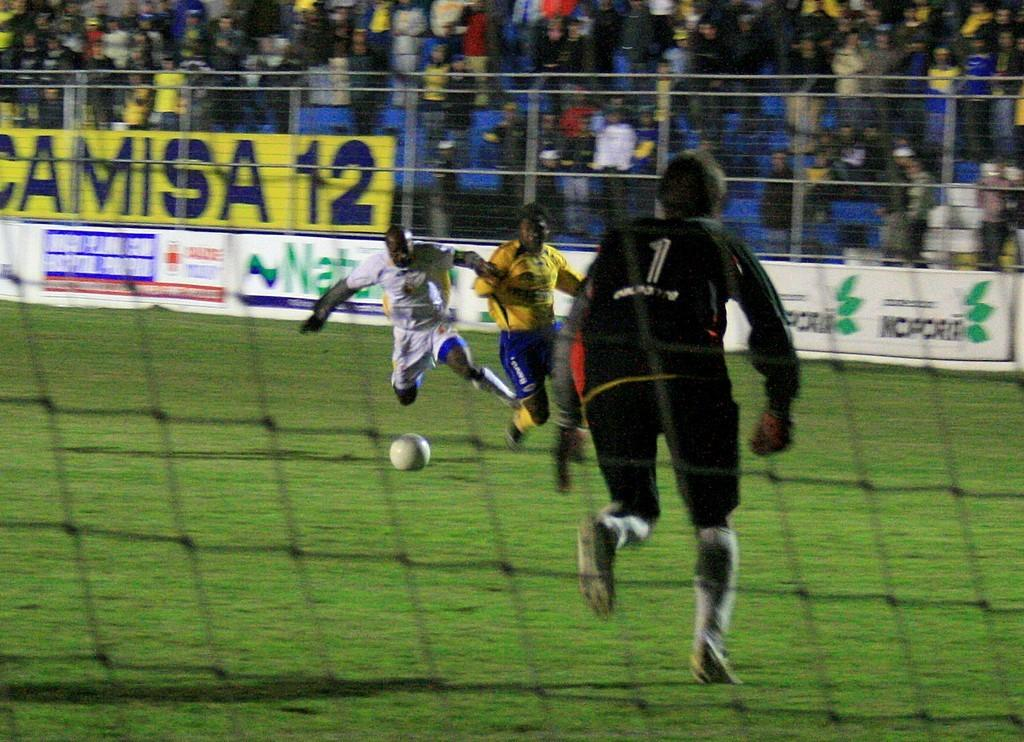Provide a one-sentence caption for the provided image. A soccer game is underway with a full stadium of fans cheering behind a yellow sign that says Camisa 12. 